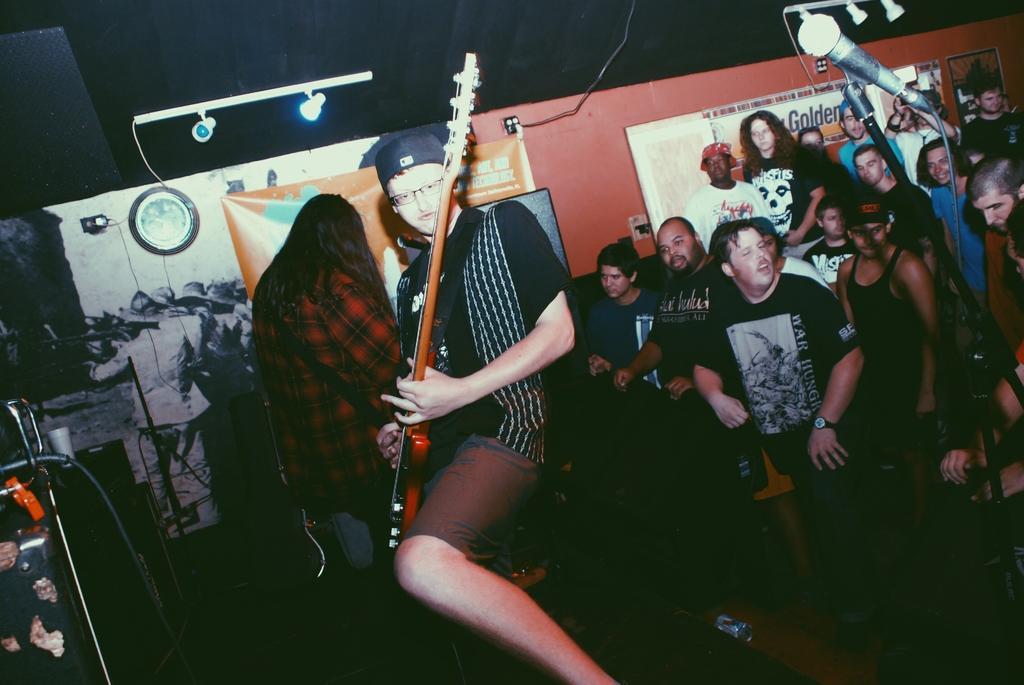Describe this image in one or two sentences. In the picture I can see a person wearing black T-shirt is standing and playing guitar and there is another person behind him and there is a mic in the right corner and there are few persons and some other objects in the background. 